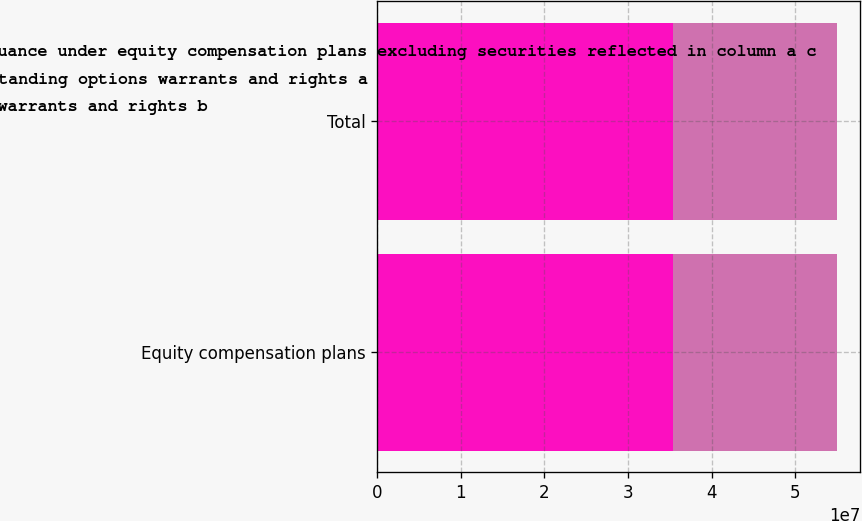Convert chart to OTSL. <chart><loc_0><loc_0><loc_500><loc_500><stacked_bar_chart><ecel><fcel>Equity compensation plans<fcel>Total<nl><fcel>Number of securities remaining available for future issuance under equity compensation plans excluding securities reflected in column a c<fcel>3.53488e+07<fcel>3.53488e+07<nl><fcel>Number of securities to be issued upon exercise of outstanding options warrants and rights a<fcel>24.16<fcel>24.16<nl><fcel>Weighted average exercise price of outstanding options warrants and rights b<fcel>1.96443e+07<fcel>1.96443e+07<nl></chart> 